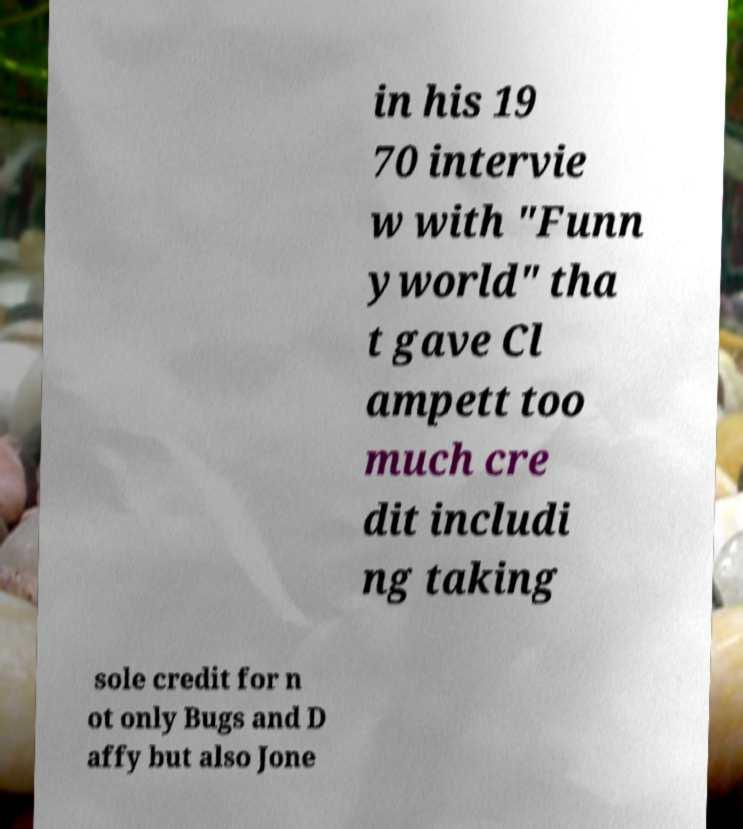Can you accurately transcribe the text from the provided image for me? in his 19 70 intervie w with "Funn yworld" tha t gave Cl ampett too much cre dit includi ng taking sole credit for n ot only Bugs and D affy but also Jone 